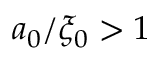Convert formula to latex. <formula><loc_0><loc_0><loc_500><loc_500>a _ { 0 } / \xi _ { 0 } > 1</formula> 